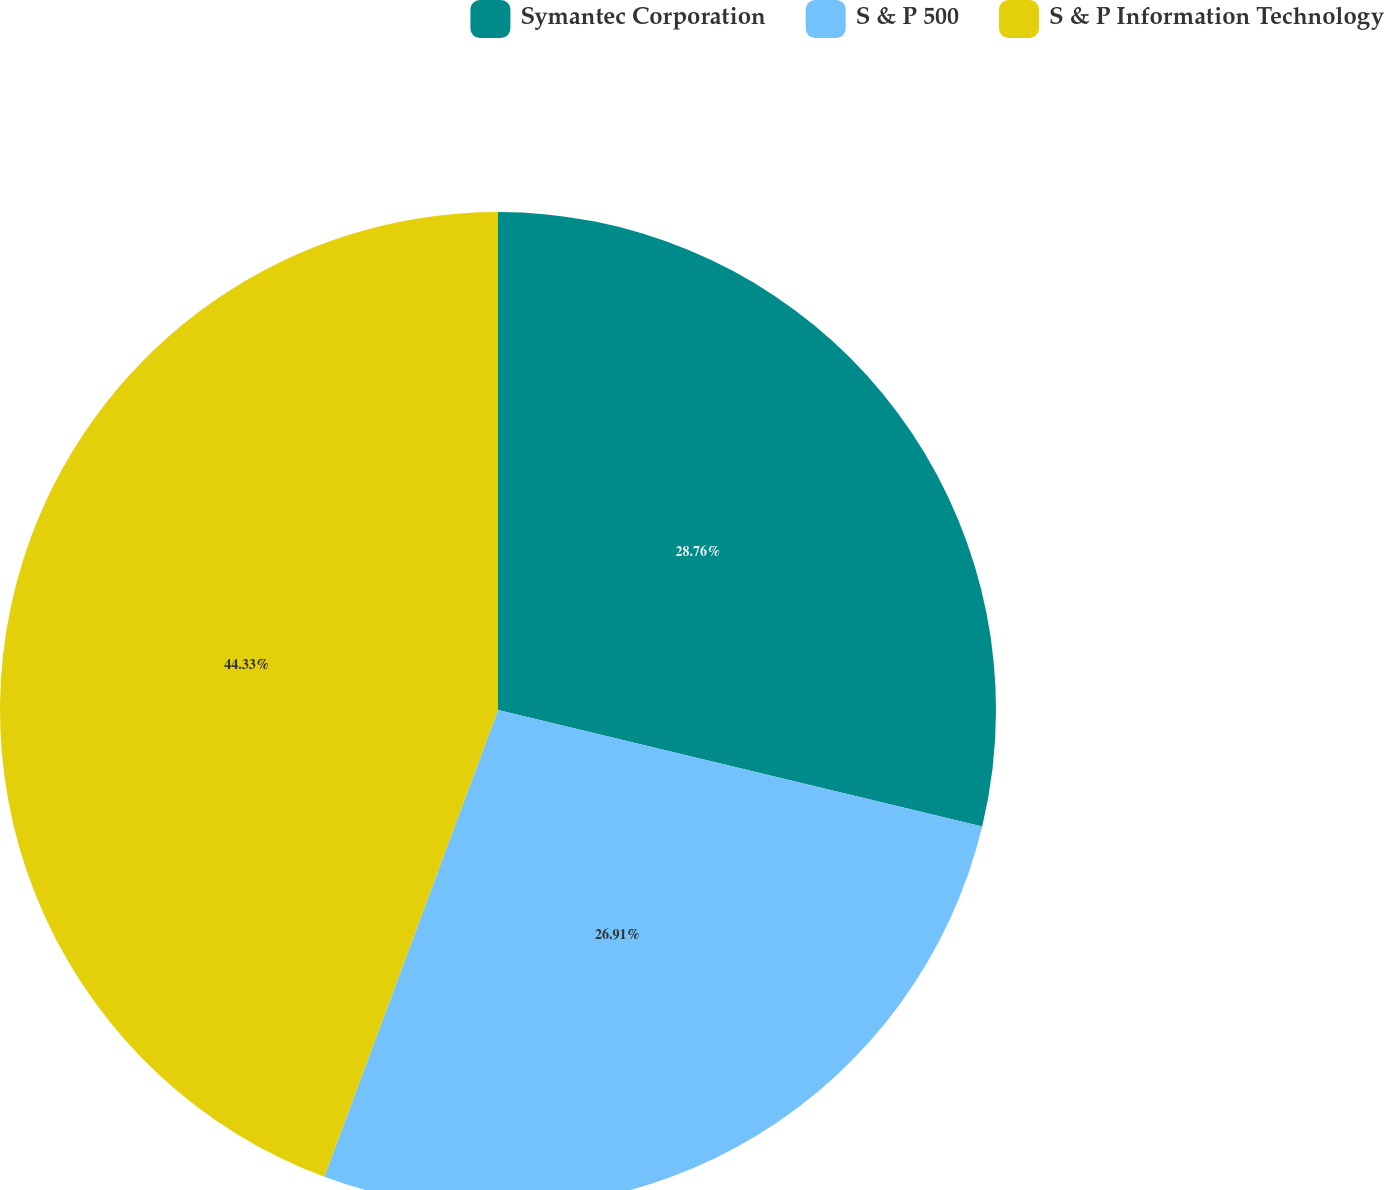Convert chart. <chart><loc_0><loc_0><loc_500><loc_500><pie_chart><fcel>Symantec Corporation<fcel>S & P 500<fcel>S & P Information Technology<nl><fcel>28.76%<fcel>26.91%<fcel>44.33%<nl></chart> 